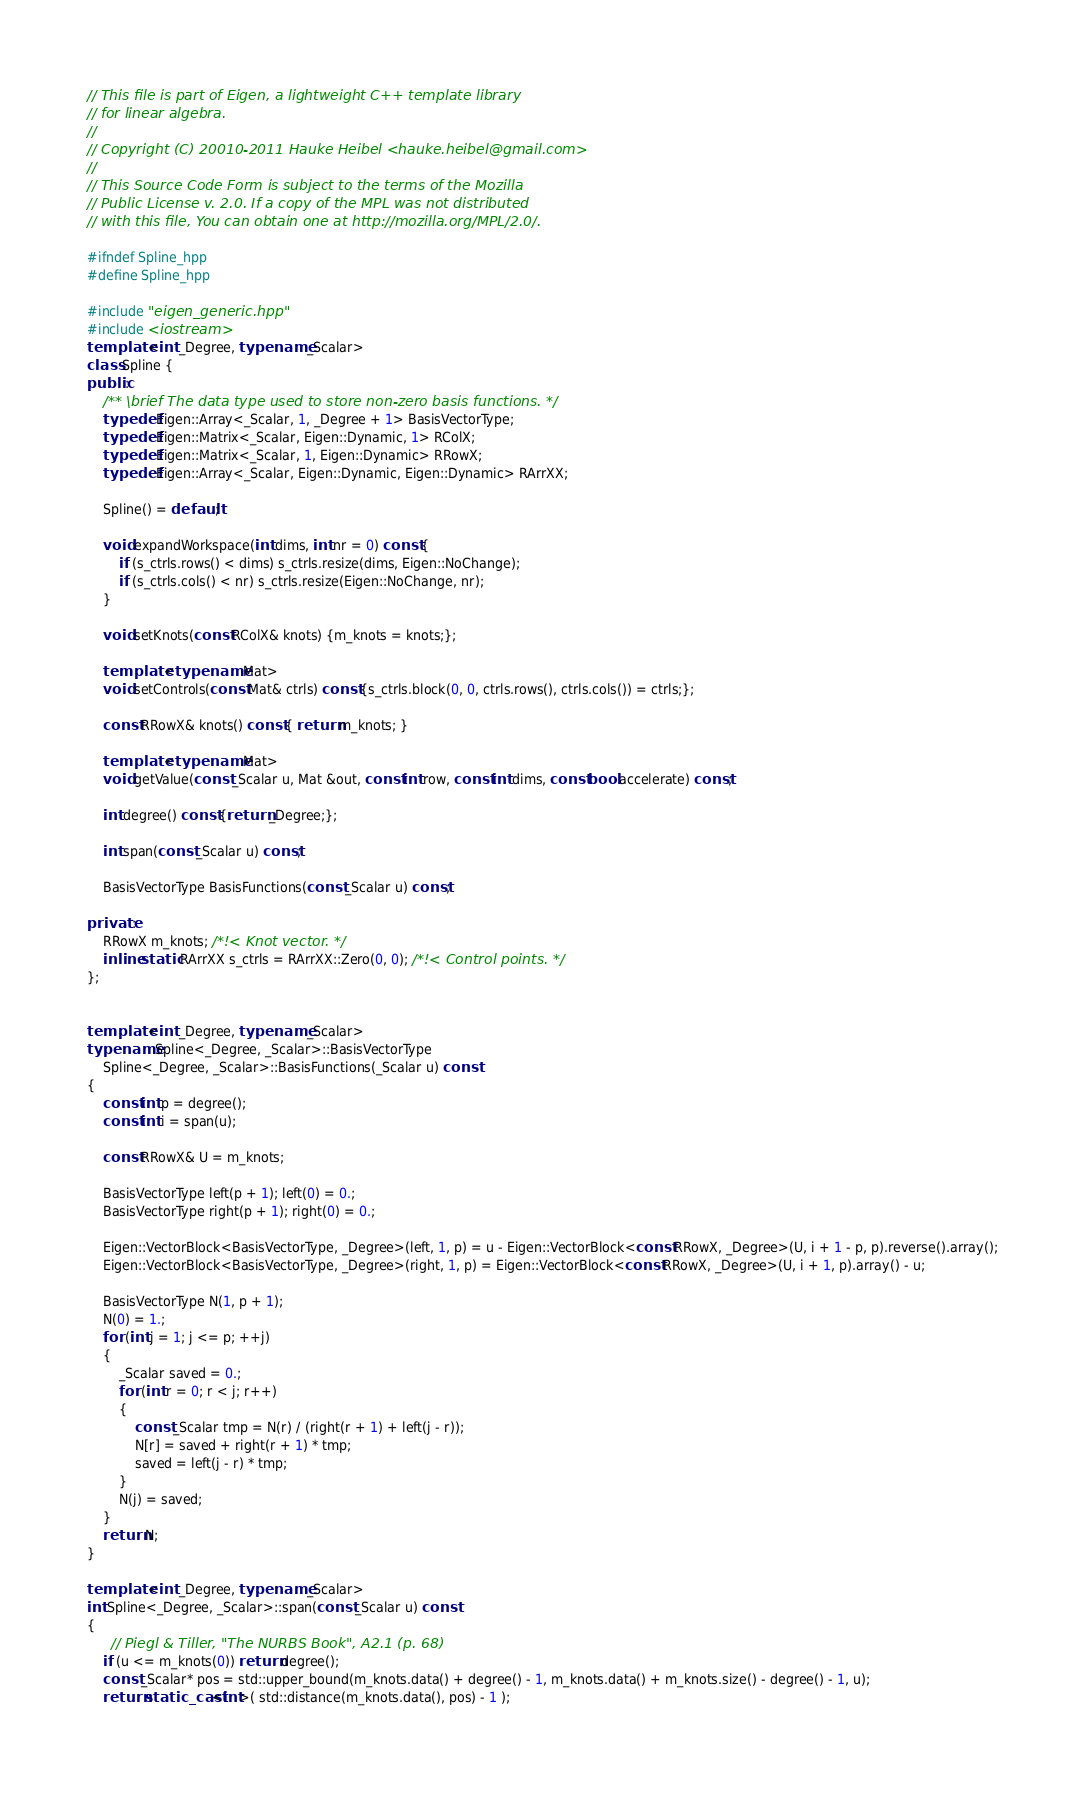<code> <loc_0><loc_0><loc_500><loc_500><_C++_>// This file is part of Eigen, a lightweight C++ template library
// for linear algebra.
//
// Copyright (C) 20010-2011 Hauke Heibel <hauke.heibel@gmail.com>
//
// This Source Code Form is subject to the terms of the Mozilla
// Public License v. 2.0. If a copy of the MPL was not distributed
// with this file, You can obtain one at http://mozilla.org/MPL/2.0/.

#ifndef Spline_hpp
#define Spline_hpp

#include "eigen_generic.hpp"
#include <iostream>
template <int _Degree, typename _Scalar>
class Spline {
public:
    /** \brief The data type used to store non-zero basis functions. */
    typedef Eigen::Array<_Scalar, 1, _Degree + 1> BasisVectorType;
    typedef Eigen::Matrix<_Scalar, Eigen::Dynamic, 1> RColX;
    typedef Eigen::Matrix<_Scalar, 1, Eigen::Dynamic> RRowX;
    typedef Eigen::Array<_Scalar, Eigen::Dynamic, Eigen::Dynamic> RArrXX;

    Spline() = default;
    
    void expandWorkspace(int dims, int nr = 0) const {
        if (s_ctrls.rows() < dims) s_ctrls.resize(dims, Eigen::NoChange);
        if (s_ctrls.cols() < nr) s_ctrls.resize(Eigen::NoChange, nr);
    }

    void setKnots(const RColX& knots) {m_knots = knots;};
    
    template <typename Mat>
    void setControls(const Mat& ctrls) const {s_ctrls.block(0, 0, ctrls.rows(), ctrls.cols()) = ctrls;};

    const RRowX& knots() const { return m_knots; }
    
    template <typename Mat>
    void getValue(const _Scalar u, Mat &out, const int row, const int dims, const bool accelerate) const;

    int degree() const {return _Degree;};

    int span(const _Scalar u) const;
    
    BasisVectorType BasisFunctions(const _Scalar u) const;

private:
    RRowX m_knots; /*!< Knot vector. */
    inline static RArrXX s_ctrls = RArrXX::Zero(0, 0); /*!< Control points. */
};


template <int _Degree, typename _Scalar>
typename Spline<_Degree, _Scalar>::BasisVectorType
    Spline<_Degree, _Scalar>::BasisFunctions(_Scalar u) const
{
    const int p = degree();
    const int i = span(u);

    const RRowX& U = m_knots;

    BasisVectorType left(p + 1); left(0) = 0.;
    BasisVectorType right(p + 1); right(0) = 0.;

    Eigen::VectorBlock<BasisVectorType, _Degree>(left, 1, p) = u - Eigen::VectorBlock<const RRowX, _Degree>(U, i + 1 - p, p).reverse().array();
    Eigen::VectorBlock<BasisVectorType, _Degree>(right, 1, p) = Eigen::VectorBlock<const RRowX, _Degree>(U, i + 1, p).array() - u;

    BasisVectorType N(1, p + 1);
    N(0) = 1.;
    for (int j = 1; j <= p; ++j)
    {
        _Scalar saved = 0.;
        for (int r = 0; r < j; r++)
        {
            const _Scalar tmp = N(r) / (right(r + 1) + left(j - r));
            N[r] = saved + right(r + 1) * tmp;
            saved = left(j - r) * tmp;
        }
        N(j) = saved;
    }
    return N;
}

template <int _Degree, typename _Scalar>
int Spline<_Degree, _Scalar>::span(const _Scalar u) const
{
      // Piegl & Tiller, "The NURBS Book", A2.1 (p. 68)
    if (u <= m_knots(0)) return degree();
    const _Scalar* pos = std::upper_bound(m_knots.data() + degree() - 1, m_knots.data() + m_knots.size() - degree() - 1, u);
    return static_cast<int>( std::distance(m_knots.data(), pos) - 1 );</code> 